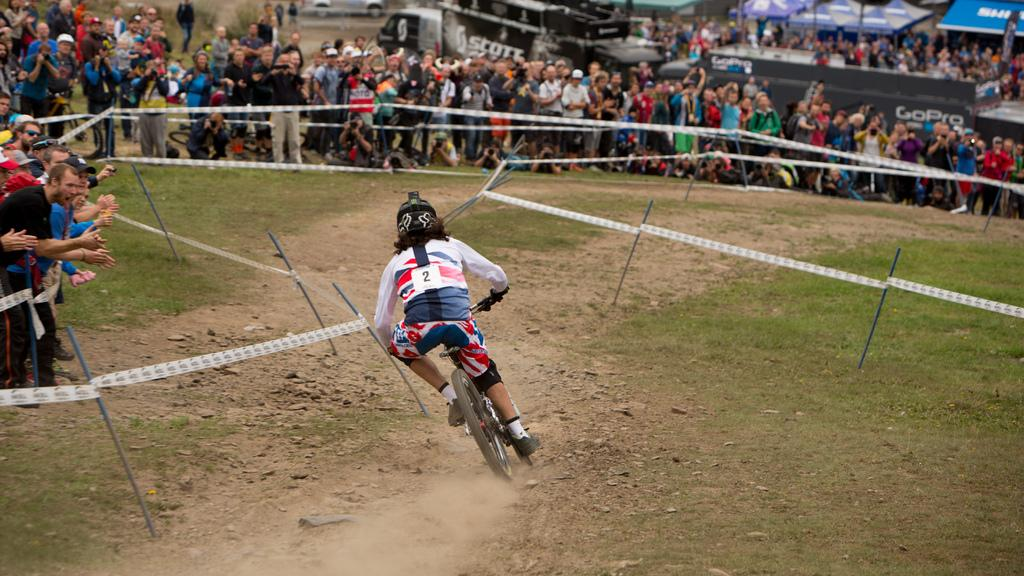<image>
Provide a brief description of the given image. A man wearing the number 1 bikes across a course as people watch and cheer him on. 